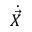<formula> <loc_0><loc_0><loc_500><loc_500>{ \dot { \vec { X } } }</formula> 